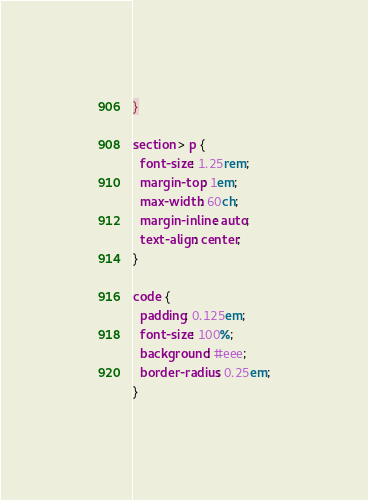<code> <loc_0><loc_0><loc_500><loc_500><_CSS_>}

section > p {
  font-size: 1.25rem;
  margin-top: 1em;
  max-width: 60ch;
  margin-inline: auto;
  text-align: center;
}

code {
  padding: 0.125em;
  font-size: 100%;
  background: #eee;
  border-radius: 0.25em;
}
</code> 